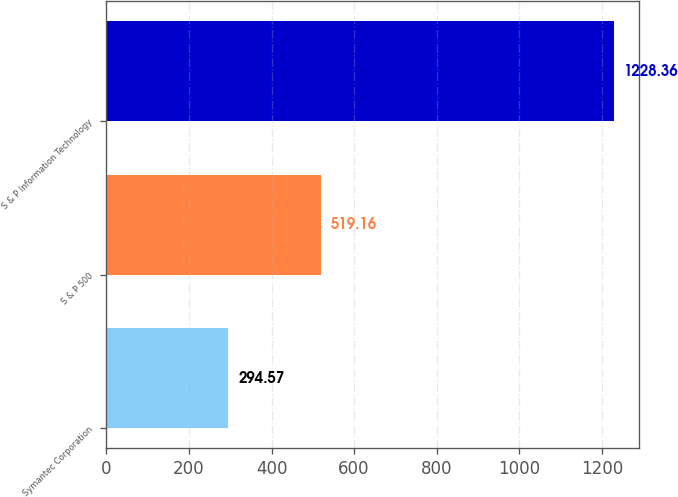<chart> <loc_0><loc_0><loc_500><loc_500><bar_chart><fcel>Symantec Corporation<fcel>S & P 500<fcel>S & P Information Technology<nl><fcel>294.57<fcel>519.16<fcel>1228.36<nl></chart> 